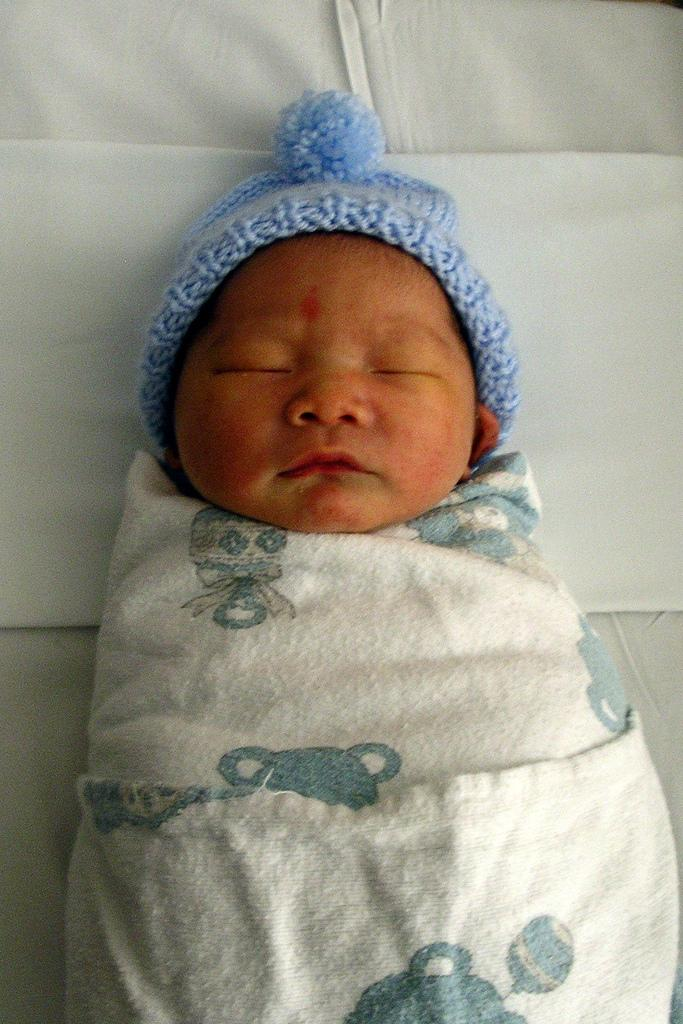What is the main subject of the image? There is a baby in the image. What is the baby wearing? The baby is wearing a white dress and a blue cap. Where is the baby located in the image? The baby is laying on the floor. What type of cub can be seen playing with the baby in the image? There is no cub present in the image, and therefore no such activity can be observed. 